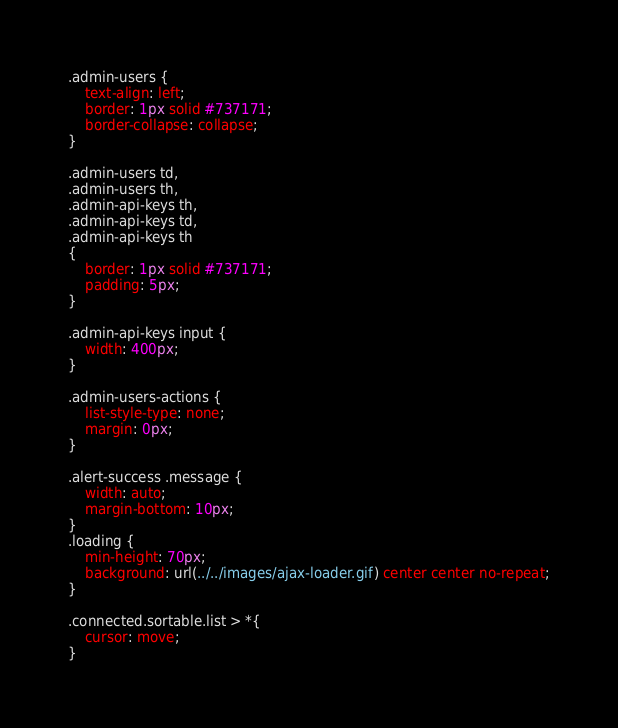<code> <loc_0><loc_0><loc_500><loc_500><_CSS_>.admin-users {
    text-align: left;
    border: 1px solid #737171;
    border-collapse: collapse;
}

.admin-users td,
.admin-users th,
.admin-api-keys th,
.admin-api-keys td,
.admin-api-keys th
{
    border: 1px solid #737171;
    padding: 5px;
}

.admin-api-keys input {
    width: 400px;
}

.admin-users-actions {
    list-style-type: none;
    margin: 0px;
}

.alert-success .message {
    width: auto;
    margin-bottom: 10px;
}
.loading {
    min-height: 70px;
    background: url(../../images/ajax-loader.gif) center center no-repeat;
}

.connected.sortable.list > *{
    cursor: move;
}</code> 